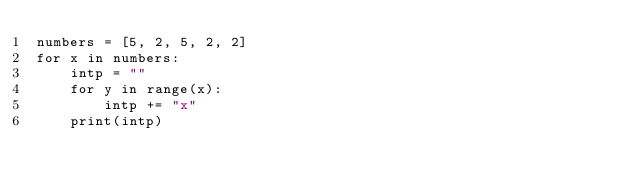<code> <loc_0><loc_0><loc_500><loc_500><_Python_>numbers = [5, 2, 5, 2, 2]
for x in numbers:
    intp = ""
    for y in range(x):
        intp += "x"
    print(intp)</code> 